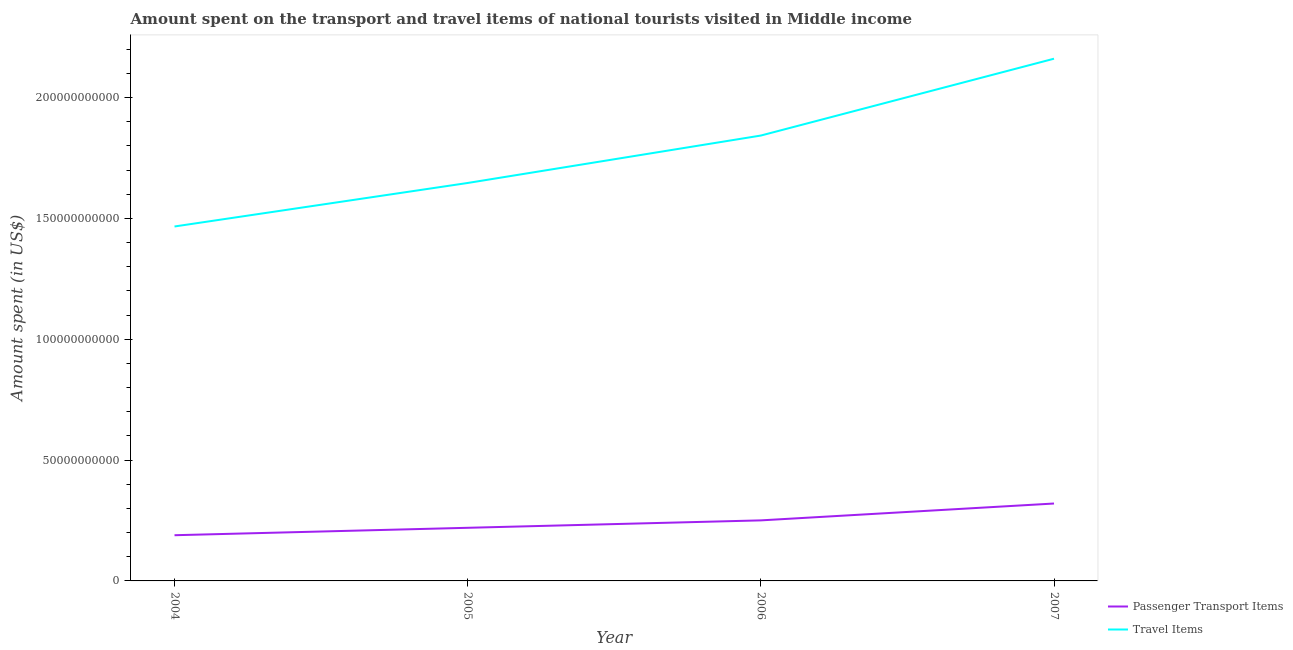How many different coloured lines are there?
Keep it short and to the point. 2. What is the amount spent in travel items in 2004?
Make the answer very short. 1.47e+11. Across all years, what is the maximum amount spent on passenger transport items?
Provide a succinct answer. 3.20e+1. Across all years, what is the minimum amount spent in travel items?
Keep it short and to the point. 1.47e+11. In which year was the amount spent on passenger transport items maximum?
Your answer should be very brief. 2007. What is the total amount spent in travel items in the graph?
Keep it short and to the point. 7.12e+11. What is the difference between the amount spent in travel items in 2004 and that in 2005?
Ensure brevity in your answer.  -1.80e+1. What is the difference between the amount spent in travel items in 2004 and the amount spent on passenger transport items in 2007?
Keep it short and to the point. 1.15e+11. What is the average amount spent in travel items per year?
Your answer should be compact. 1.78e+11. In the year 2004, what is the difference between the amount spent in travel items and amount spent on passenger transport items?
Provide a succinct answer. 1.28e+11. What is the ratio of the amount spent in travel items in 2004 to that in 2005?
Provide a short and direct response. 0.89. Is the amount spent on passenger transport items in 2004 less than that in 2007?
Provide a succinct answer. Yes. What is the difference between the highest and the second highest amount spent on passenger transport items?
Offer a very short reply. 6.97e+09. What is the difference between the highest and the lowest amount spent on passenger transport items?
Provide a short and direct response. 1.31e+1. In how many years, is the amount spent on passenger transport items greater than the average amount spent on passenger transport items taken over all years?
Your response must be concise. 2. Is the sum of the amount spent in travel items in 2004 and 2006 greater than the maximum amount spent on passenger transport items across all years?
Give a very brief answer. Yes. Does the amount spent on passenger transport items monotonically increase over the years?
Give a very brief answer. Yes. Is the amount spent on passenger transport items strictly greater than the amount spent in travel items over the years?
Make the answer very short. No. Is the amount spent on passenger transport items strictly less than the amount spent in travel items over the years?
Make the answer very short. Yes. How many lines are there?
Offer a terse response. 2. How many years are there in the graph?
Give a very brief answer. 4. What is the difference between two consecutive major ticks on the Y-axis?
Your answer should be very brief. 5.00e+1. How are the legend labels stacked?
Give a very brief answer. Vertical. What is the title of the graph?
Keep it short and to the point. Amount spent on the transport and travel items of national tourists visited in Middle income. Does "Attending school" appear as one of the legend labels in the graph?
Your response must be concise. No. What is the label or title of the X-axis?
Offer a terse response. Year. What is the label or title of the Y-axis?
Your response must be concise. Amount spent (in US$). What is the Amount spent (in US$) of Passenger Transport Items in 2004?
Make the answer very short. 1.89e+1. What is the Amount spent (in US$) in Travel Items in 2004?
Your answer should be compact. 1.47e+11. What is the Amount spent (in US$) in Passenger Transport Items in 2005?
Give a very brief answer. 2.20e+1. What is the Amount spent (in US$) of Travel Items in 2005?
Provide a short and direct response. 1.65e+11. What is the Amount spent (in US$) in Passenger Transport Items in 2006?
Offer a very short reply. 2.51e+1. What is the Amount spent (in US$) in Travel Items in 2006?
Provide a short and direct response. 1.84e+11. What is the Amount spent (in US$) of Passenger Transport Items in 2007?
Make the answer very short. 3.20e+1. What is the Amount spent (in US$) in Travel Items in 2007?
Keep it short and to the point. 2.16e+11. Across all years, what is the maximum Amount spent (in US$) of Passenger Transport Items?
Give a very brief answer. 3.20e+1. Across all years, what is the maximum Amount spent (in US$) of Travel Items?
Your answer should be compact. 2.16e+11. Across all years, what is the minimum Amount spent (in US$) in Passenger Transport Items?
Your answer should be compact. 1.89e+1. Across all years, what is the minimum Amount spent (in US$) of Travel Items?
Ensure brevity in your answer.  1.47e+11. What is the total Amount spent (in US$) of Passenger Transport Items in the graph?
Ensure brevity in your answer.  9.80e+1. What is the total Amount spent (in US$) in Travel Items in the graph?
Provide a short and direct response. 7.12e+11. What is the difference between the Amount spent (in US$) in Passenger Transport Items in 2004 and that in 2005?
Provide a short and direct response. -3.07e+09. What is the difference between the Amount spent (in US$) in Travel Items in 2004 and that in 2005?
Ensure brevity in your answer.  -1.80e+1. What is the difference between the Amount spent (in US$) in Passenger Transport Items in 2004 and that in 2006?
Give a very brief answer. -6.15e+09. What is the difference between the Amount spent (in US$) of Travel Items in 2004 and that in 2006?
Give a very brief answer. -3.76e+1. What is the difference between the Amount spent (in US$) in Passenger Transport Items in 2004 and that in 2007?
Provide a short and direct response. -1.31e+1. What is the difference between the Amount spent (in US$) in Travel Items in 2004 and that in 2007?
Your response must be concise. -6.94e+1. What is the difference between the Amount spent (in US$) in Passenger Transport Items in 2005 and that in 2006?
Your answer should be compact. -3.08e+09. What is the difference between the Amount spent (in US$) of Travel Items in 2005 and that in 2006?
Keep it short and to the point. -1.96e+1. What is the difference between the Amount spent (in US$) of Passenger Transport Items in 2005 and that in 2007?
Provide a short and direct response. -1.00e+1. What is the difference between the Amount spent (in US$) of Travel Items in 2005 and that in 2007?
Give a very brief answer. -5.14e+1. What is the difference between the Amount spent (in US$) in Passenger Transport Items in 2006 and that in 2007?
Offer a terse response. -6.97e+09. What is the difference between the Amount spent (in US$) in Travel Items in 2006 and that in 2007?
Make the answer very short. -3.18e+1. What is the difference between the Amount spent (in US$) of Passenger Transport Items in 2004 and the Amount spent (in US$) of Travel Items in 2005?
Your answer should be very brief. -1.46e+11. What is the difference between the Amount spent (in US$) in Passenger Transport Items in 2004 and the Amount spent (in US$) in Travel Items in 2006?
Offer a terse response. -1.65e+11. What is the difference between the Amount spent (in US$) in Passenger Transport Items in 2004 and the Amount spent (in US$) in Travel Items in 2007?
Your answer should be very brief. -1.97e+11. What is the difference between the Amount spent (in US$) in Passenger Transport Items in 2005 and the Amount spent (in US$) in Travel Items in 2006?
Make the answer very short. -1.62e+11. What is the difference between the Amount spent (in US$) in Passenger Transport Items in 2005 and the Amount spent (in US$) in Travel Items in 2007?
Your answer should be compact. -1.94e+11. What is the difference between the Amount spent (in US$) in Passenger Transport Items in 2006 and the Amount spent (in US$) in Travel Items in 2007?
Your answer should be very brief. -1.91e+11. What is the average Amount spent (in US$) of Passenger Transport Items per year?
Make the answer very short. 2.45e+1. What is the average Amount spent (in US$) in Travel Items per year?
Provide a succinct answer. 1.78e+11. In the year 2004, what is the difference between the Amount spent (in US$) in Passenger Transport Items and Amount spent (in US$) in Travel Items?
Your answer should be compact. -1.28e+11. In the year 2005, what is the difference between the Amount spent (in US$) in Passenger Transport Items and Amount spent (in US$) in Travel Items?
Your answer should be very brief. -1.43e+11. In the year 2006, what is the difference between the Amount spent (in US$) in Passenger Transport Items and Amount spent (in US$) in Travel Items?
Provide a short and direct response. -1.59e+11. In the year 2007, what is the difference between the Amount spent (in US$) in Passenger Transport Items and Amount spent (in US$) in Travel Items?
Provide a short and direct response. -1.84e+11. What is the ratio of the Amount spent (in US$) of Passenger Transport Items in 2004 to that in 2005?
Keep it short and to the point. 0.86. What is the ratio of the Amount spent (in US$) of Travel Items in 2004 to that in 2005?
Provide a succinct answer. 0.89. What is the ratio of the Amount spent (in US$) in Passenger Transport Items in 2004 to that in 2006?
Ensure brevity in your answer.  0.75. What is the ratio of the Amount spent (in US$) in Travel Items in 2004 to that in 2006?
Ensure brevity in your answer.  0.8. What is the ratio of the Amount spent (in US$) in Passenger Transport Items in 2004 to that in 2007?
Ensure brevity in your answer.  0.59. What is the ratio of the Amount spent (in US$) in Travel Items in 2004 to that in 2007?
Offer a very short reply. 0.68. What is the ratio of the Amount spent (in US$) of Passenger Transport Items in 2005 to that in 2006?
Your response must be concise. 0.88. What is the ratio of the Amount spent (in US$) of Travel Items in 2005 to that in 2006?
Provide a short and direct response. 0.89. What is the ratio of the Amount spent (in US$) of Passenger Transport Items in 2005 to that in 2007?
Give a very brief answer. 0.69. What is the ratio of the Amount spent (in US$) in Travel Items in 2005 to that in 2007?
Offer a very short reply. 0.76. What is the ratio of the Amount spent (in US$) of Passenger Transport Items in 2006 to that in 2007?
Keep it short and to the point. 0.78. What is the ratio of the Amount spent (in US$) of Travel Items in 2006 to that in 2007?
Make the answer very short. 0.85. What is the difference between the highest and the second highest Amount spent (in US$) of Passenger Transport Items?
Make the answer very short. 6.97e+09. What is the difference between the highest and the second highest Amount spent (in US$) of Travel Items?
Provide a short and direct response. 3.18e+1. What is the difference between the highest and the lowest Amount spent (in US$) of Passenger Transport Items?
Keep it short and to the point. 1.31e+1. What is the difference between the highest and the lowest Amount spent (in US$) in Travel Items?
Provide a succinct answer. 6.94e+1. 